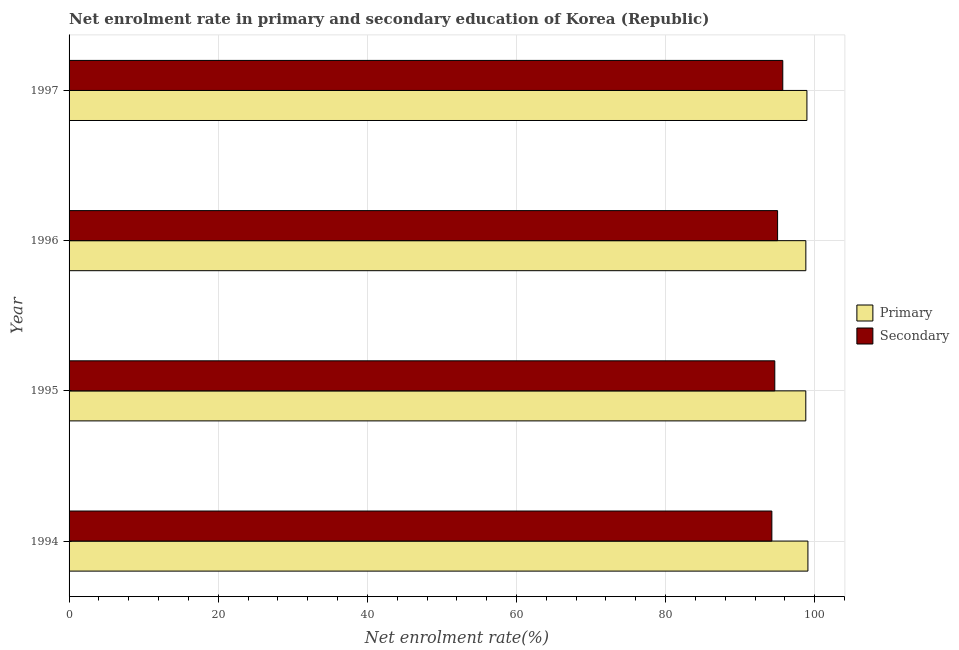Are the number of bars on each tick of the Y-axis equal?
Ensure brevity in your answer.  Yes. How many bars are there on the 2nd tick from the top?
Your response must be concise. 2. How many bars are there on the 3rd tick from the bottom?
Your response must be concise. 2. What is the enrollment rate in primary education in 1995?
Your answer should be very brief. 98.8. Across all years, what is the maximum enrollment rate in secondary education?
Give a very brief answer. 95.71. Across all years, what is the minimum enrollment rate in secondary education?
Your answer should be compact. 94.25. What is the total enrollment rate in primary education in the graph?
Your response must be concise. 395.63. What is the difference between the enrollment rate in primary education in 1994 and that in 1995?
Ensure brevity in your answer.  0.28. What is the difference between the enrollment rate in secondary education in 1996 and the enrollment rate in primary education in 1997?
Keep it short and to the point. -3.93. What is the average enrollment rate in primary education per year?
Keep it short and to the point. 98.91. In the year 1995, what is the difference between the enrollment rate in primary education and enrollment rate in secondary education?
Give a very brief answer. 4.16. In how many years, is the enrollment rate in secondary education greater than 52 %?
Ensure brevity in your answer.  4. What is the difference between the highest and the second highest enrollment rate in secondary education?
Offer a terse response. 0.69. What is the difference between the highest and the lowest enrollment rate in primary education?
Give a very brief answer. 0.29. Is the sum of the enrollment rate in primary education in 1994 and 1996 greater than the maximum enrollment rate in secondary education across all years?
Your response must be concise. Yes. What does the 2nd bar from the top in 1997 represents?
Your response must be concise. Primary. What does the 1st bar from the bottom in 1994 represents?
Offer a terse response. Primary. Are the values on the major ticks of X-axis written in scientific E-notation?
Give a very brief answer. No. Does the graph contain any zero values?
Your answer should be compact. No. What is the title of the graph?
Ensure brevity in your answer.  Net enrolment rate in primary and secondary education of Korea (Republic). What is the label or title of the X-axis?
Your response must be concise. Net enrolment rate(%). What is the label or title of the Y-axis?
Offer a very short reply. Year. What is the Net enrolment rate(%) of Primary in 1994?
Ensure brevity in your answer.  99.08. What is the Net enrolment rate(%) in Secondary in 1994?
Keep it short and to the point. 94.25. What is the Net enrolment rate(%) in Primary in 1995?
Keep it short and to the point. 98.8. What is the Net enrolment rate(%) in Secondary in 1995?
Keep it short and to the point. 94.64. What is the Net enrolment rate(%) in Primary in 1996?
Give a very brief answer. 98.8. What is the Net enrolment rate(%) of Secondary in 1996?
Give a very brief answer. 95.02. What is the Net enrolment rate(%) in Primary in 1997?
Make the answer very short. 98.95. What is the Net enrolment rate(%) of Secondary in 1997?
Ensure brevity in your answer.  95.71. Across all years, what is the maximum Net enrolment rate(%) in Primary?
Give a very brief answer. 99.08. Across all years, what is the maximum Net enrolment rate(%) in Secondary?
Make the answer very short. 95.71. Across all years, what is the minimum Net enrolment rate(%) of Primary?
Ensure brevity in your answer.  98.8. Across all years, what is the minimum Net enrolment rate(%) in Secondary?
Keep it short and to the point. 94.25. What is the total Net enrolment rate(%) in Primary in the graph?
Your answer should be very brief. 395.63. What is the total Net enrolment rate(%) of Secondary in the graph?
Provide a short and direct response. 379.62. What is the difference between the Net enrolment rate(%) in Primary in 1994 and that in 1995?
Your answer should be compact. 0.29. What is the difference between the Net enrolment rate(%) of Secondary in 1994 and that in 1995?
Your answer should be compact. -0.39. What is the difference between the Net enrolment rate(%) of Primary in 1994 and that in 1996?
Provide a short and direct response. 0.28. What is the difference between the Net enrolment rate(%) in Secondary in 1994 and that in 1996?
Make the answer very short. -0.77. What is the difference between the Net enrolment rate(%) in Primary in 1994 and that in 1997?
Provide a succinct answer. 0.14. What is the difference between the Net enrolment rate(%) of Secondary in 1994 and that in 1997?
Offer a very short reply. -1.46. What is the difference between the Net enrolment rate(%) in Primary in 1995 and that in 1996?
Keep it short and to the point. -0.01. What is the difference between the Net enrolment rate(%) in Secondary in 1995 and that in 1996?
Provide a succinct answer. -0.38. What is the difference between the Net enrolment rate(%) in Primary in 1995 and that in 1997?
Your answer should be compact. -0.15. What is the difference between the Net enrolment rate(%) of Secondary in 1995 and that in 1997?
Provide a succinct answer. -1.07. What is the difference between the Net enrolment rate(%) of Primary in 1996 and that in 1997?
Ensure brevity in your answer.  -0.14. What is the difference between the Net enrolment rate(%) of Secondary in 1996 and that in 1997?
Provide a succinct answer. -0.7. What is the difference between the Net enrolment rate(%) in Primary in 1994 and the Net enrolment rate(%) in Secondary in 1995?
Provide a short and direct response. 4.44. What is the difference between the Net enrolment rate(%) of Primary in 1994 and the Net enrolment rate(%) of Secondary in 1996?
Ensure brevity in your answer.  4.07. What is the difference between the Net enrolment rate(%) of Primary in 1994 and the Net enrolment rate(%) of Secondary in 1997?
Offer a very short reply. 3.37. What is the difference between the Net enrolment rate(%) of Primary in 1995 and the Net enrolment rate(%) of Secondary in 1996?
Your answer should be compact. 3.78. What is the difference between the Net enrolment rate(%) in Primary in 1995 and the Net enrolment rate(%) in Secondary in 1997?
Your response must be concise. 3.09. What is the difference between the Net enrolment rate(%) of Primary in 1996 and the Net enrolment rate(%) of Secondary in 1997?
Your response must be concise. 3.09. What is the average Net enrolment rate(%) in Primary per year?
Provide a short and direct response. 98.91. What is the average Net enrolment rate(%) in Secondary per year?
Your response must be concise. 94.9. In the year 1994, what is the difference between the Net enrolment rate(%) in Primary and Net enrolment rate(%) in Secondary?
Your answer should be very brief. 4.84. In the year 1995, what is the difference between the Net enrolment rate(%) of Primary and Net enrolment rate(%) of Secondary?
Your answer should be very brief. 4.16. In the year 1996, what is the difference between the Net enrolment rate(%) of Primary and Net enrolment rate(%) of Secondary?
Give a very brief answer. 3.79. In the year 1997, what is the difference between the Net enrolment rate(%) of Primary and Net enrolment rate(%) of Secondary?
Keep it short and to the point. 3.24. What is the ratio of the Net enrolment rate(%) of Secondary in 1994 to that in 1995?
Your answer should be compact. 1. What is the ratio of the Net enrolment rate(%) of Primary in 1994 to that in 1997?
Your answer should be very brief. 1. What is the ratio of the Net enrolment rate(%) of Secondary in 1994 to that in 1997?
Make the answer very short. 0.98. What is the ratio of the Net enrolment rate(%) in Primary in 1995 to that in 1997?
Keep it short and to the point. 1. What is the ratio of the Net enrolment rate(%) in Secondary in 1995 to that in 1997?
Provide a short and direct response. 0.99. What is the ratio of the Net enrolment rate(%) in Primary in 1996 to that in 1997?
Make the answer very short. 1. What is the difference between the highest and the second highest Net enrolment rate(%) in Primary?
Ensure brevity in your answer.  0.14. What is the difference between the highest and the second highest Net enrolment rate(%) of Secondary?
Your answer should be compact. 0.7. What is the difference between the highest and the lowest Net enrolment rate(%) of Primary?
Your answer should be very brief. 0.29. What is the difference between the highest and the lowest Net enrolment rate(%) of Secondary?
Ensure brevity in your answer.  1.46. 